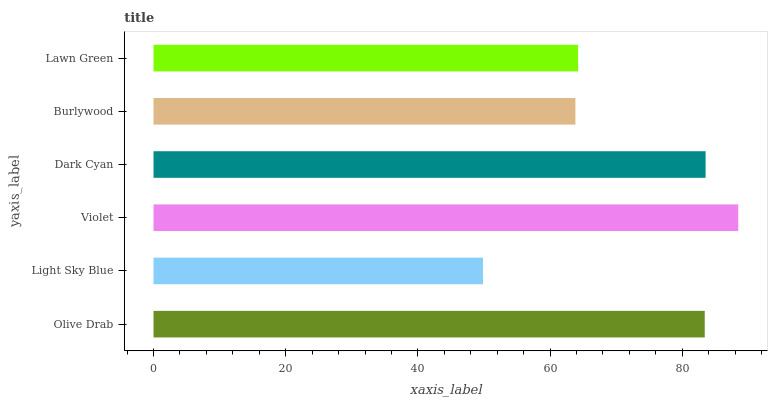Is Light Sky Blue the minimum?
Answer yes or no. Yes. Is Violet the maximum?
Answer yes or no. Yes. Is Violet the minimum?
Answer yes or no. No. Is Light Sky Blue the maximum?
Answer yes or no. No. Is Violet greater than Light Sky Blue?
Answer yes or no. Yes. Is Light Sky Blue less than Violet?
Answer yes or no. Yes. Is Light Sky Blue greater than Violet?
Answer yes or no. No. Is Violet less than Light Sky Blue?
Answer yes or no. No. Is Olive Drab the high median?
Answer yes or no. Yes. Is Lawn Green the low median?
Answer yes or no. Yes. Is Dark Cyan the high median?
Answer yes or no. No. Is Violet the low median?
Answer yes or no. No. 